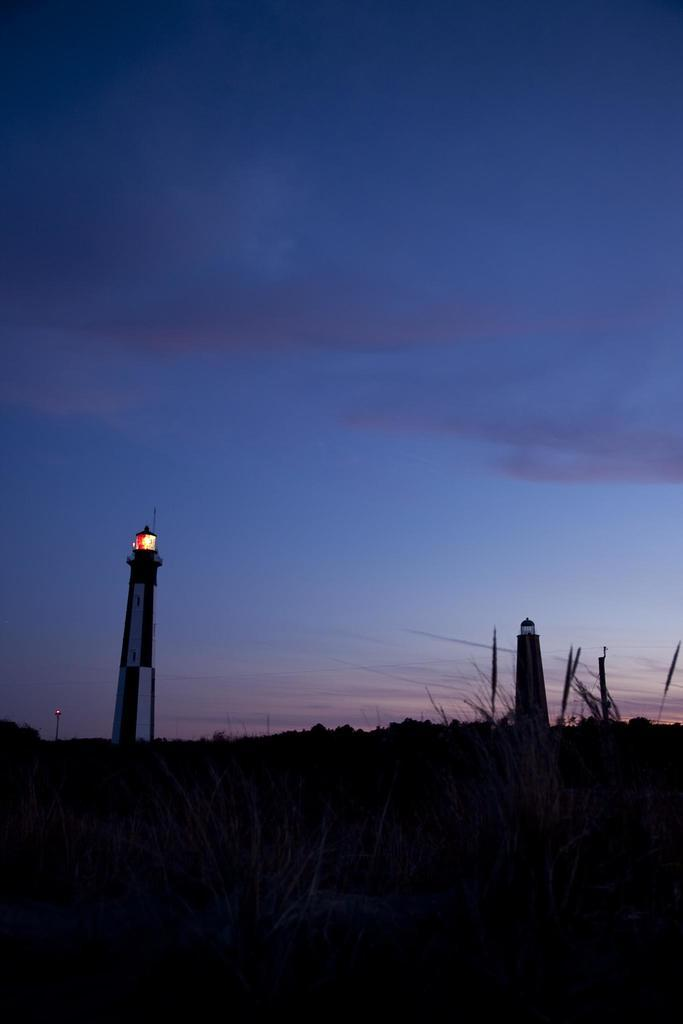What can be seen in the sky in the image? The image contains a beautiful sky. What structures are present in the image? There are lighthouses in the image. Is there any indication of the lighthouses being functional? Yes, light is visible from one of the lighthouses. What type of mint is growing near the lighthouses in the image? There is no mint visible in the image; it features a beautiful sky and lighthouses. Can you tell me how many shoes are present in the image? There are no shoes present in the image; it focuses on the sky and lighthouses. 